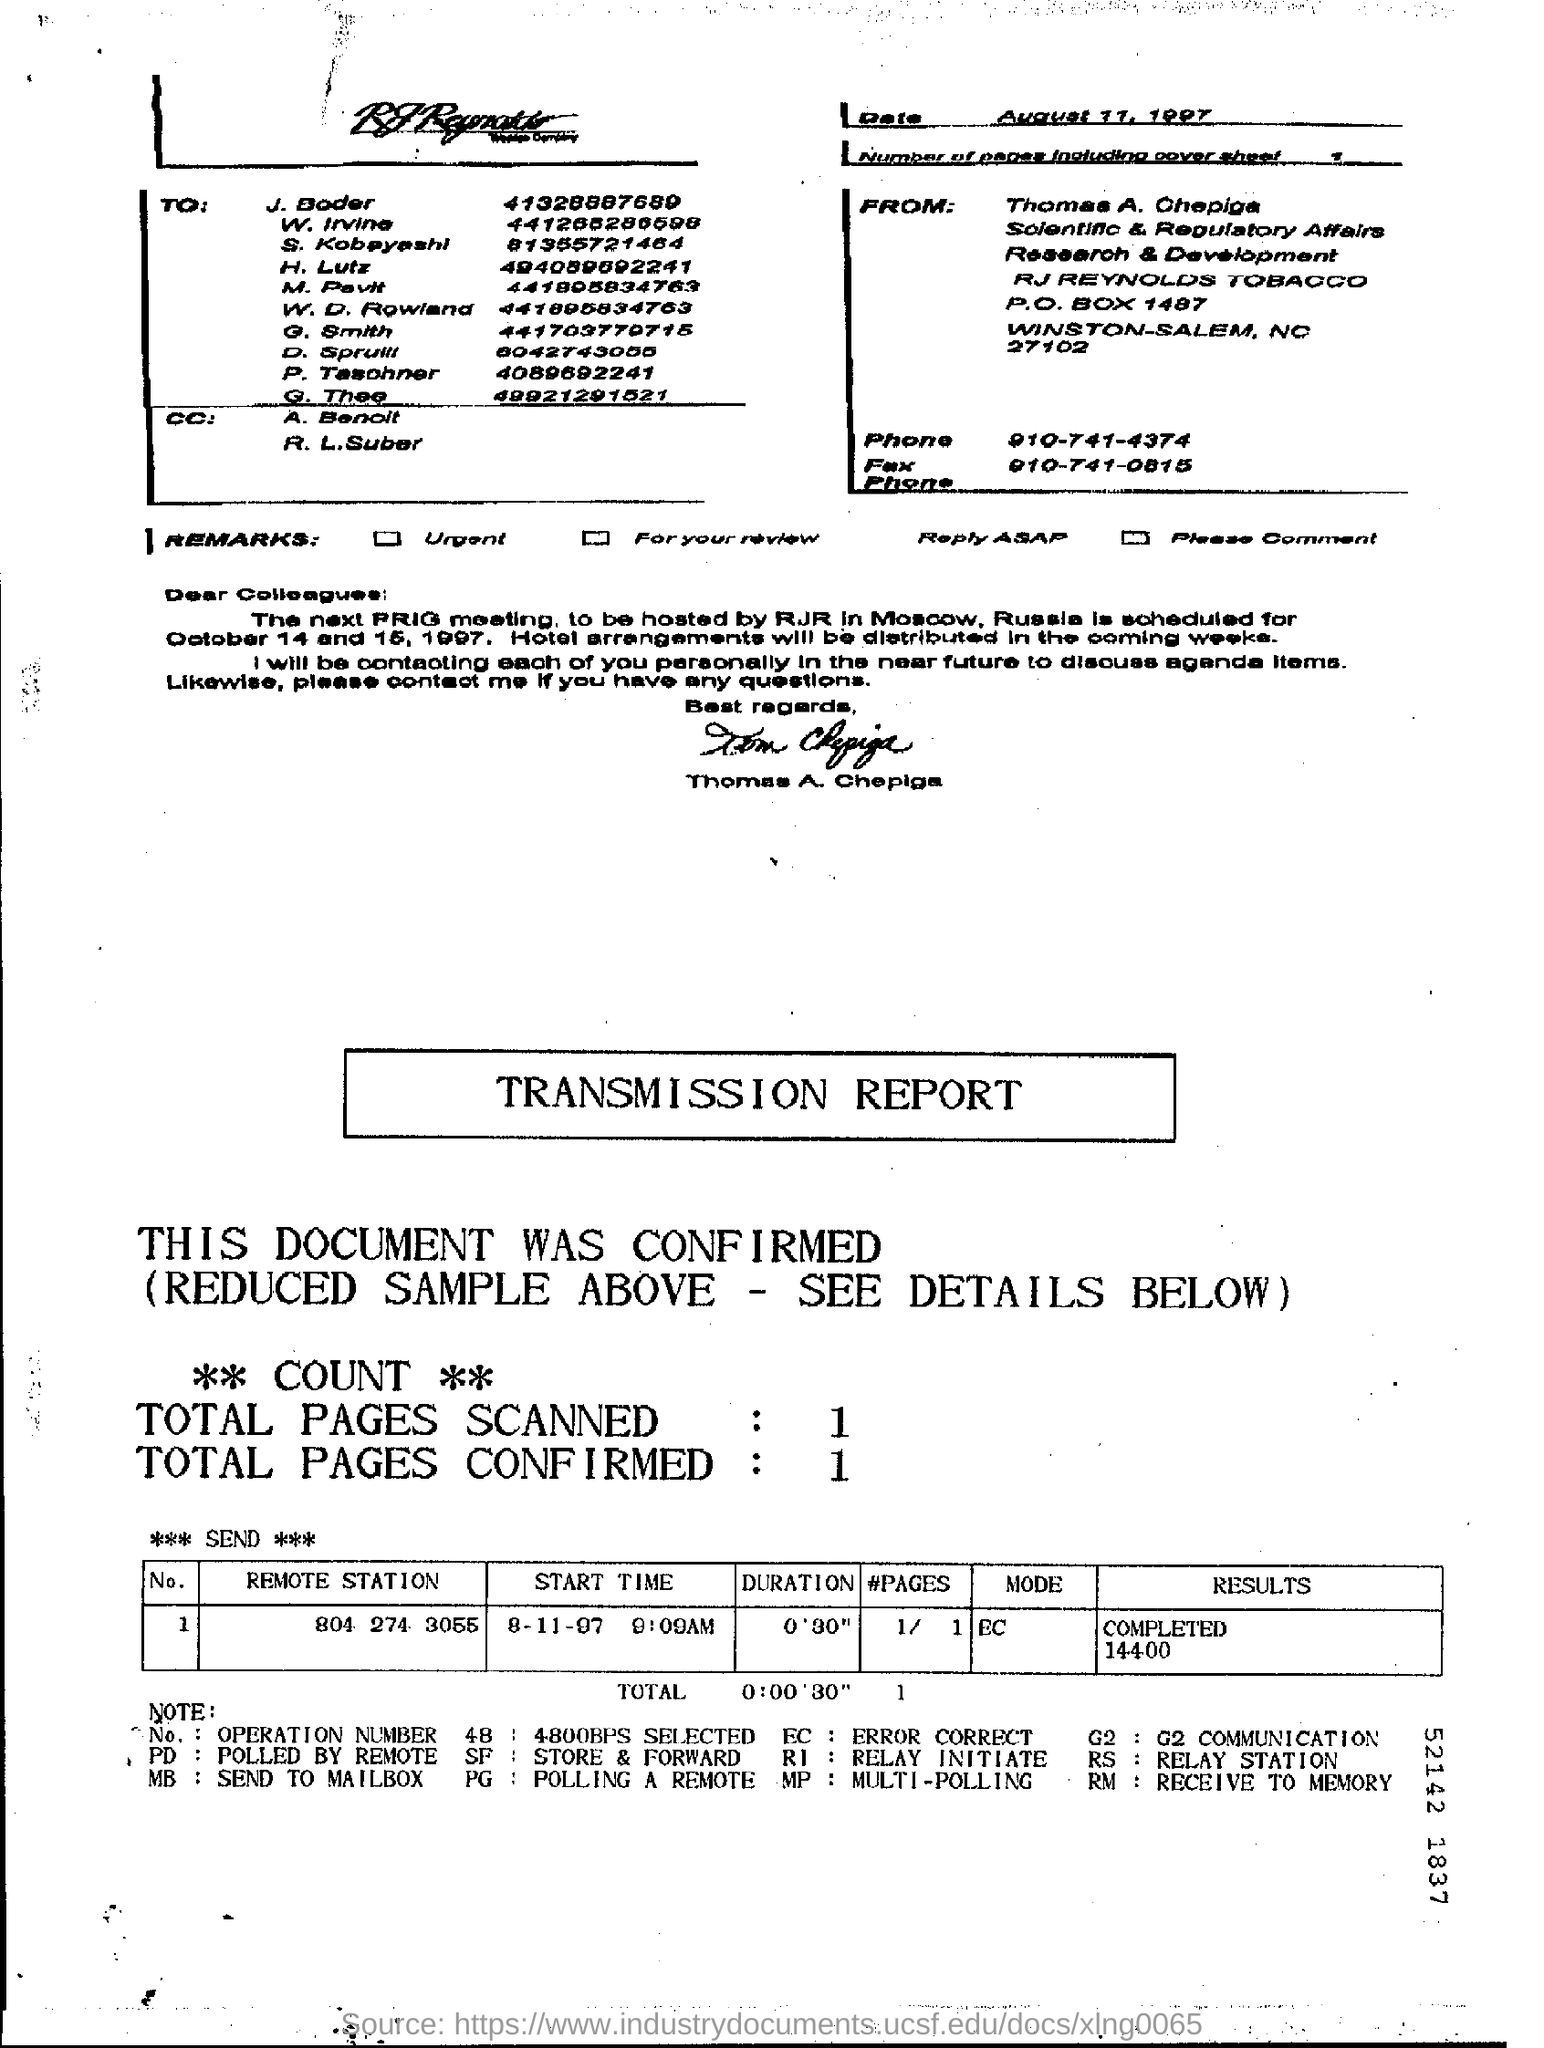What is the date on the document?
Provide a succinct answer. August 11, 1997. Who is this letter from?
Provide a succinct answer. Thomas A. Chepiga. What is the "Duration" for the "Remote Station" "804 274 3055"?
Provide a succinct answer. 0'30". What is the "MODE" for the "Remote Station" "804 274 3055"?
Offer a very short reply. EC. What are the Total Pages Scanned?
Your answer should be compact. 1. What are the Total Pages Confirmed?
Make the answer very short. 1. 